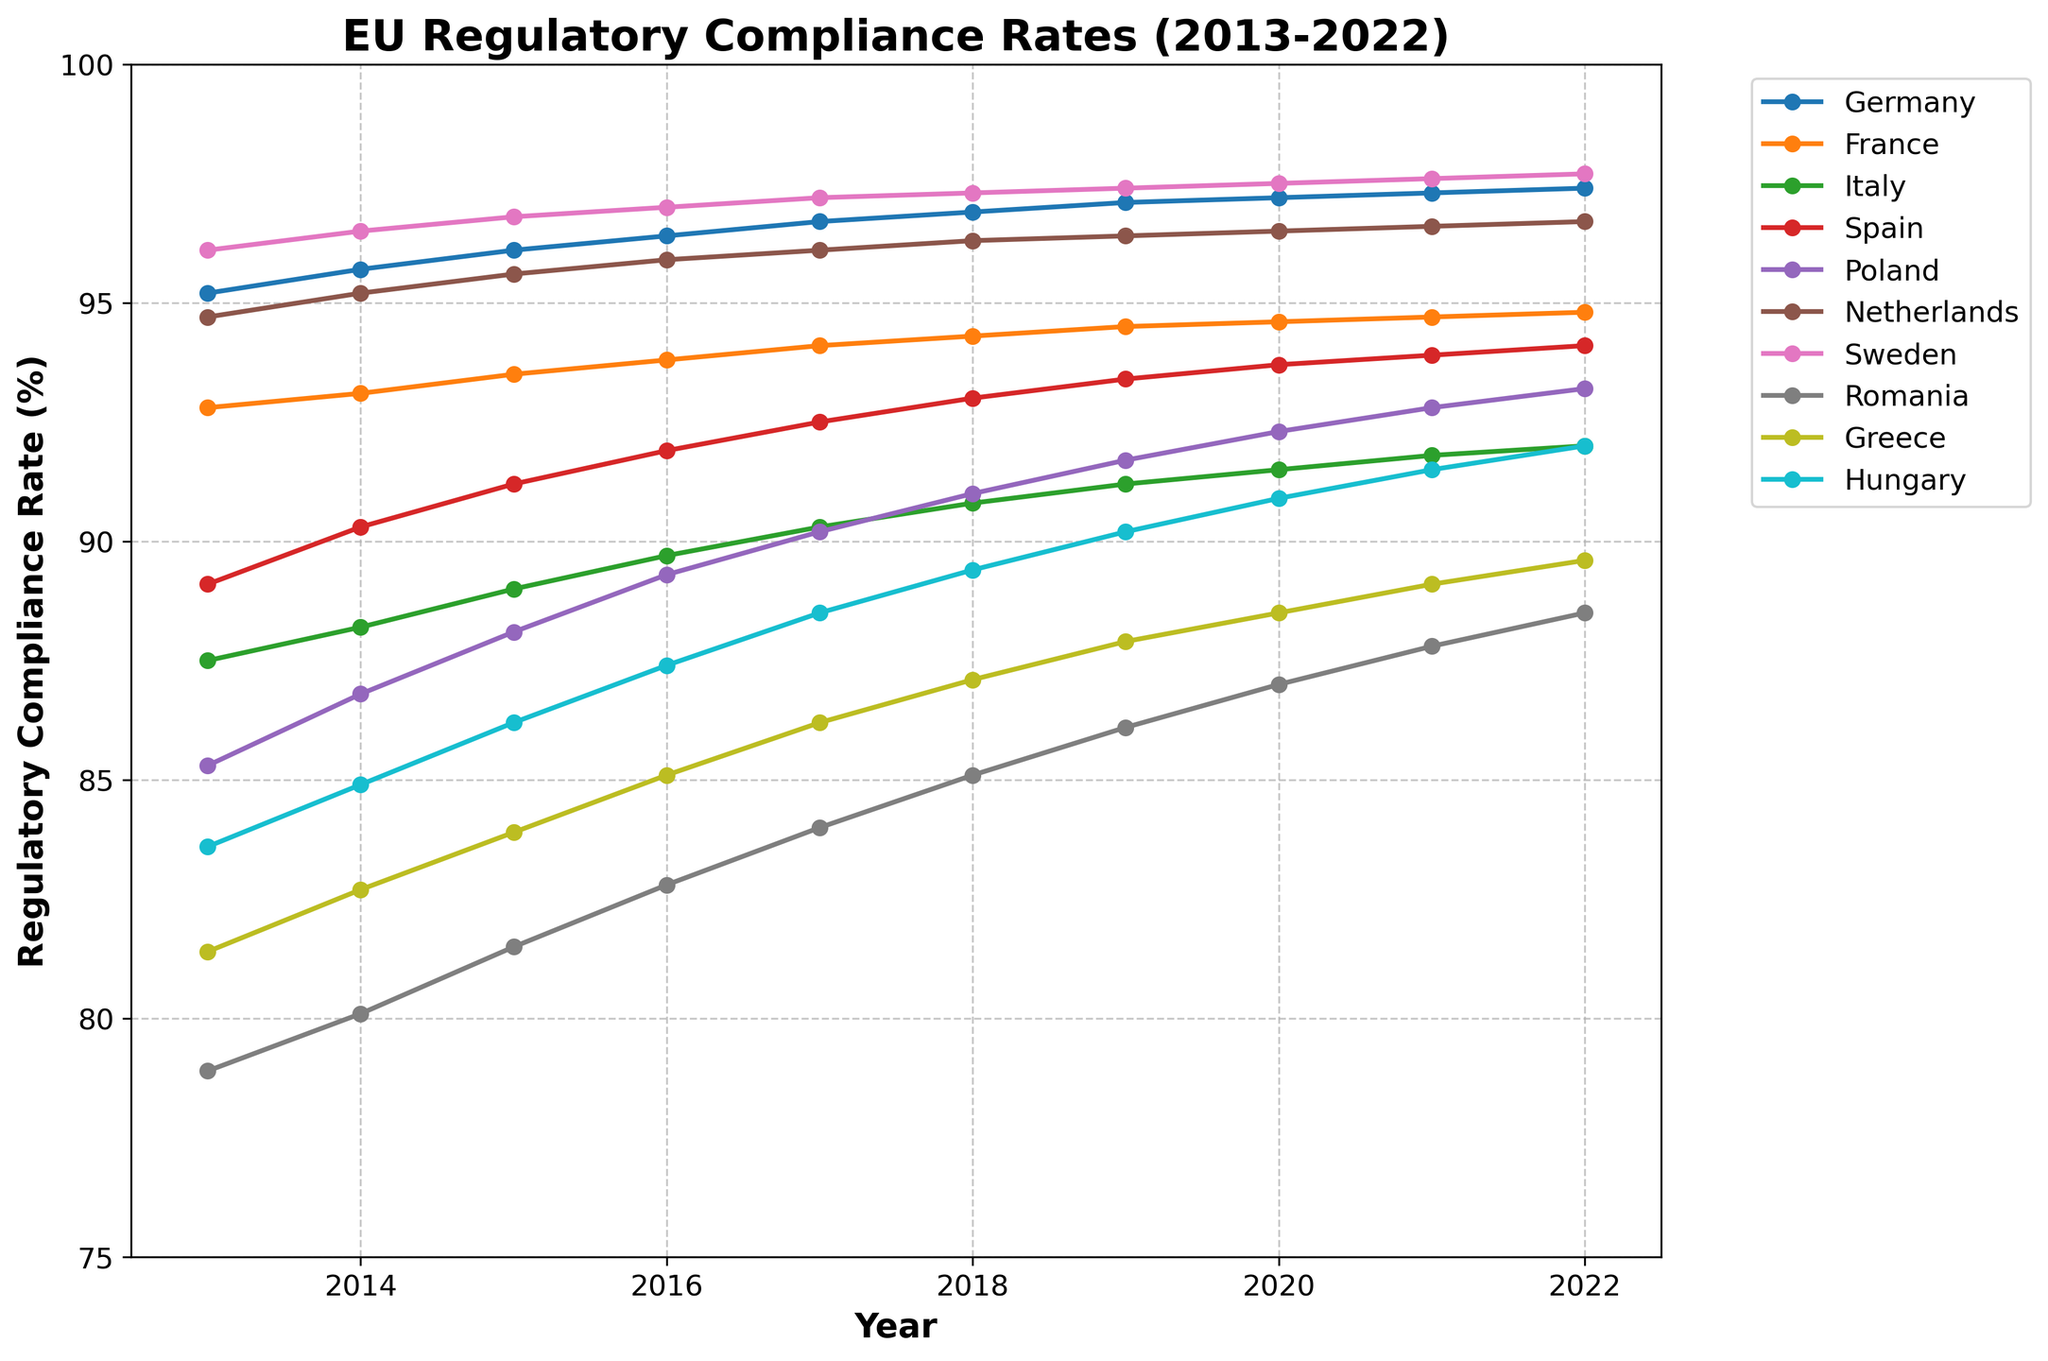What is the overall trend for Sweden from 2013 to 2022? Examine the points for Sweden from 2013 to 2022. The compliance rate consistently increases over the years.
Answer: Increasing trend Which country had the lowest regulatory compliance rate in 2013? Look at the starting points for each line in 2013. The lowest compliance rate in 2013 is for Romania at 78.9%.
Answer: Romania What is the average compliance rate of Germany over the decade? Sum the compliance rates for Germany from 2013 to 2022 (95.2 + 95.7 + 96.1 + 96.4 + 96.7 + 96.9 + 97.1 + 97.2 + 97.3 + 97.4) = 96.0%. Divide the sum by 10 for the average.
Answer: 96.0% Which two countries showed the most similar compliance rates in 2019? Compare the 2019 points for all countries. France and Italy show similar rates at 94.5% and 91.2%, respectively.
Answer: France and Italy When did Poland's compliance rate first exceed 90%? Analyze Poland's line, which crosses the 90% mark between 2016 and 2017 at 90.2%.
Answer: 2017 By how much did Italy's compliance rate change from 2013 to 2022? Subtract Italy's rate in 2013 (87.5%) from the rate in 2022 (92.0%), resulting in a change of 4.5%.
Answer: 4.5% What is the difference in compliance rate between the Netherlands and Greece in 2022? Subtract Greece's 2022 rate (89.6%) from the Netherlands' rate (96.7%), giving a difference of 7.1%.
Answer: 7.1% Which country had the highest rate in 2022, and what was it? Look at the endpoints in 2022. Sweden had the highest rate at 97.7%.
Answer: Sweden, 97.7% Which country showed the greatest improvement in compliance rate from 2013 to 2022? Compare the differences between 2013 and 2022 for all countries. Romania improved the most from 78.9% to 88.5%, an increase of 9.6%.
Answer: Romania, 9.6% 